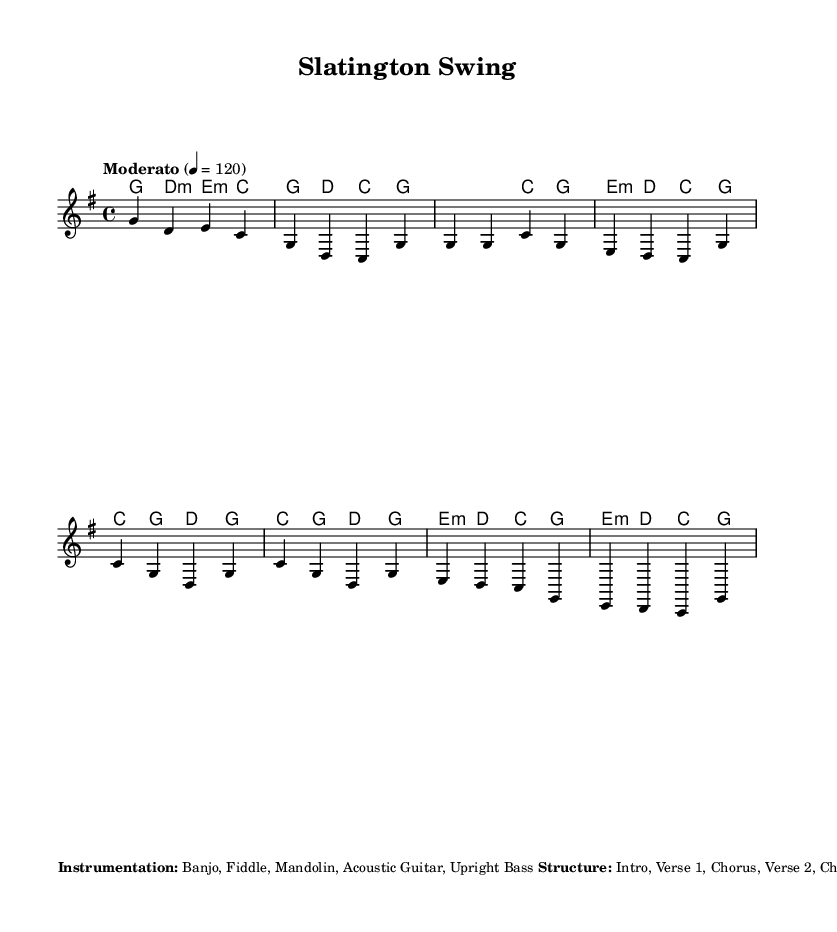What is the key signature of this music? The key signature is G major, which includes one sharp (F#). It can be identified at the beginning of the score, immediately after the clef.
Answer: G major What is the time signature of this music? The time signature is 4/4, indicated at the beginning of the score, which means there are four beats per measure and the quarter note gets one beat.
Answer: 4/4 What is the tempo marking for this piece? The tempo marking is "Moderato," which is a moderate speed, indicated in the score at the beginning with the metronome marking of 120 beats per minute.
Answer: Moderato What are the primary instruments used in this composition? The primary instruments listed in the score are Banjo, Fiddle, Mandolin, Acoustic Guitar, and Upright Bass. This is located in the markup section describing instrumentation.
Answer: Banjo, Fiddle, Mandolin, Acoustic Guitar, Upright Bass How many sections are there in the structure of the piece? The structure consists of eight sections: Intro, Verse 1, Chorus, Verse 2, Chorus, Bridge, Chorus, and Outro. This is detailed in the markup section under Structure.
Answer: Eight What unique element is included during the bridge of the music? A brief fiddle solo is incorporated during the bridge, designed to mimic the sound of a baseball being hit and the crowd cheering. This special instruction is noted in the markup section.
Answer: Fiddle solo 